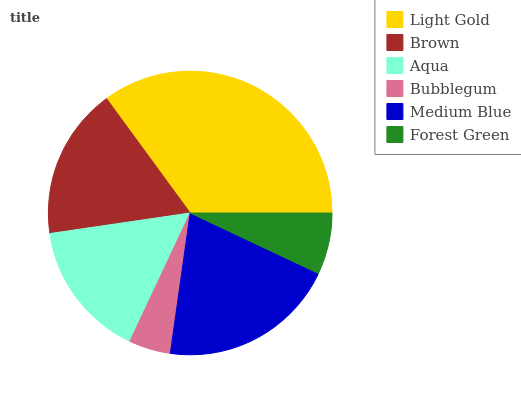Is Bubblegum the minimum?
Answer yes or no. Yes. Is Light Gold the maximum?
Answer yes or no. Yes. Is Brown the minimum?
Answer yes or no. No. Is Brown the maximum?
Answer yes or no. No. Is Light Gold greater than Brown?
Answer yes or no. Yes. Is Brown less than Light Gold?
Answer yes or no. Yes. Is Brown greater than Light Gold?
Answer yes or no. No. Is Light Gold less than Brown?
Answer yes or no. No. Is Brown the high median?
Answer yes or no. Yes. Is Aqua the low median?
Answer yes or no. Yes. Is Medium Blue the high median?
Answer yes or no. No. Is Light Gold the low median?
Answer yes or no. No. 